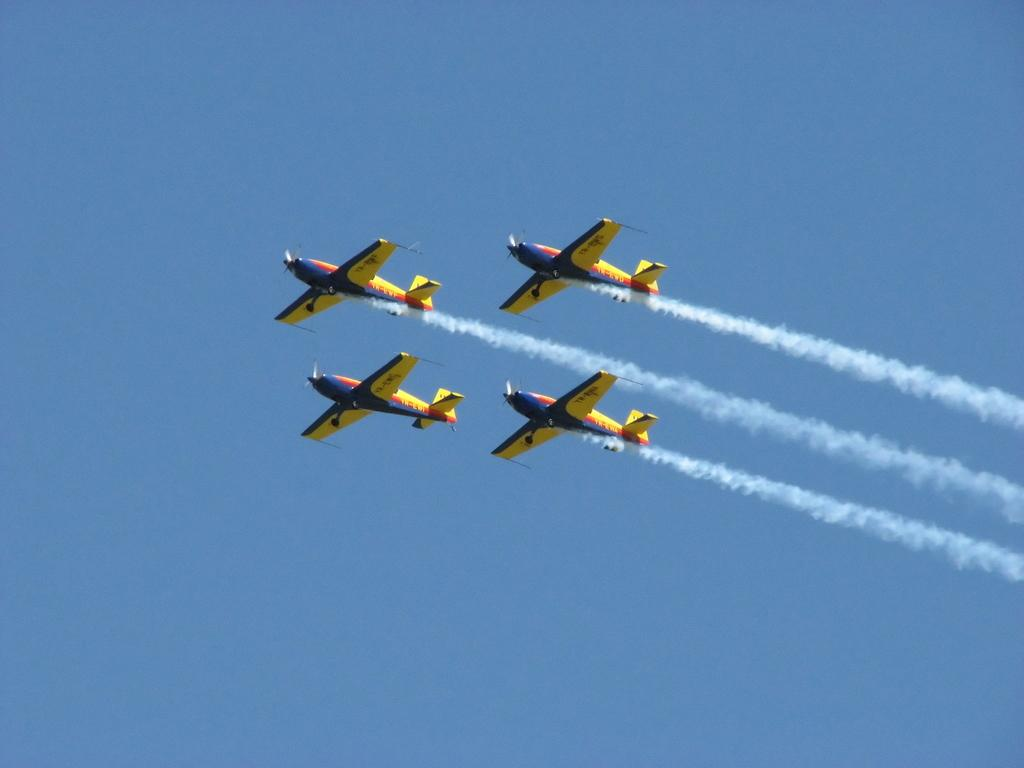What is the main subject of the image? The main subject of the image is four jet planes. What can be observed about the jet planes in the image? The jet planes have smoke coming from them. Where are the jet planes located in the image? The jet planes are flying in the sky. What type of cannon can be seen on the jet planes in the image? There are no cannons present on the jet planes in the image. How do the jet planes stop in the image? Jet planes do not stop in the image; they are flying in the sky. 